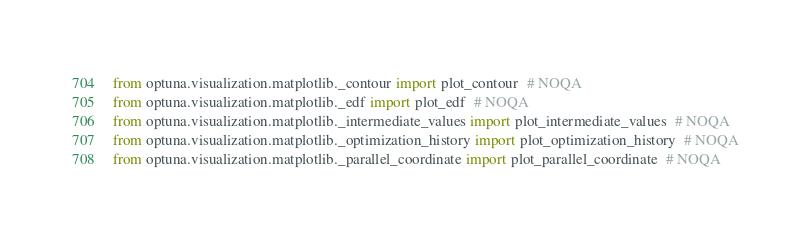<code> <loc_0><loc_0><loc_500><loc_500><_Python_>from optuna.visualization.matplotlib._contour import plot_contour  # NOQA
from optuna.visualization.matplotlib._edf import plot_edf  # NOQA
from optuna.visualization.matplotlib._intermediate_values import plot_intermediate_values  # NOQA
from optuna.visualization.matplotlib._optimization_history import plot_optimization_history  # NOQA
from optuna.visualization.matplotlib._parallel_coordinate import plot_parallel_coordinate  # NOQA</code> 